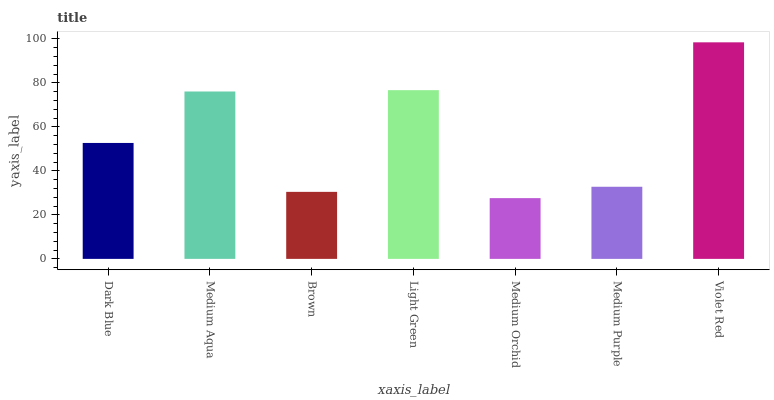Is Medium Orchid the minimum?
Answer yes or no. Yes. Is Violet Red the maximum?
Answer yes or no. Yes. Is Medium Aqua the minimum?
Answer yes or no. No. Is Medium Aqua the maximum?
Answer yes or no. No. Is Medium Aqua greater than Dark Blue?
Answer yes or no. Yes. Is Dark Blue less than Medium Aqua?
Answer yes or no. Yes. Is Dark Blue greater than Medium Aqua?
Answer yes or no. No. Is Medium Aqua less than Dark Blue?
Answer yes or no. No. Is Dark Blue the high median?
Answer yes or no. Yes. Is Dark Blue the low median?
Answer yes or no. Yes. Is Light Green the high median?
Answer yes or no. No. Is Light Green the low median?
Answer yes or no. No. 